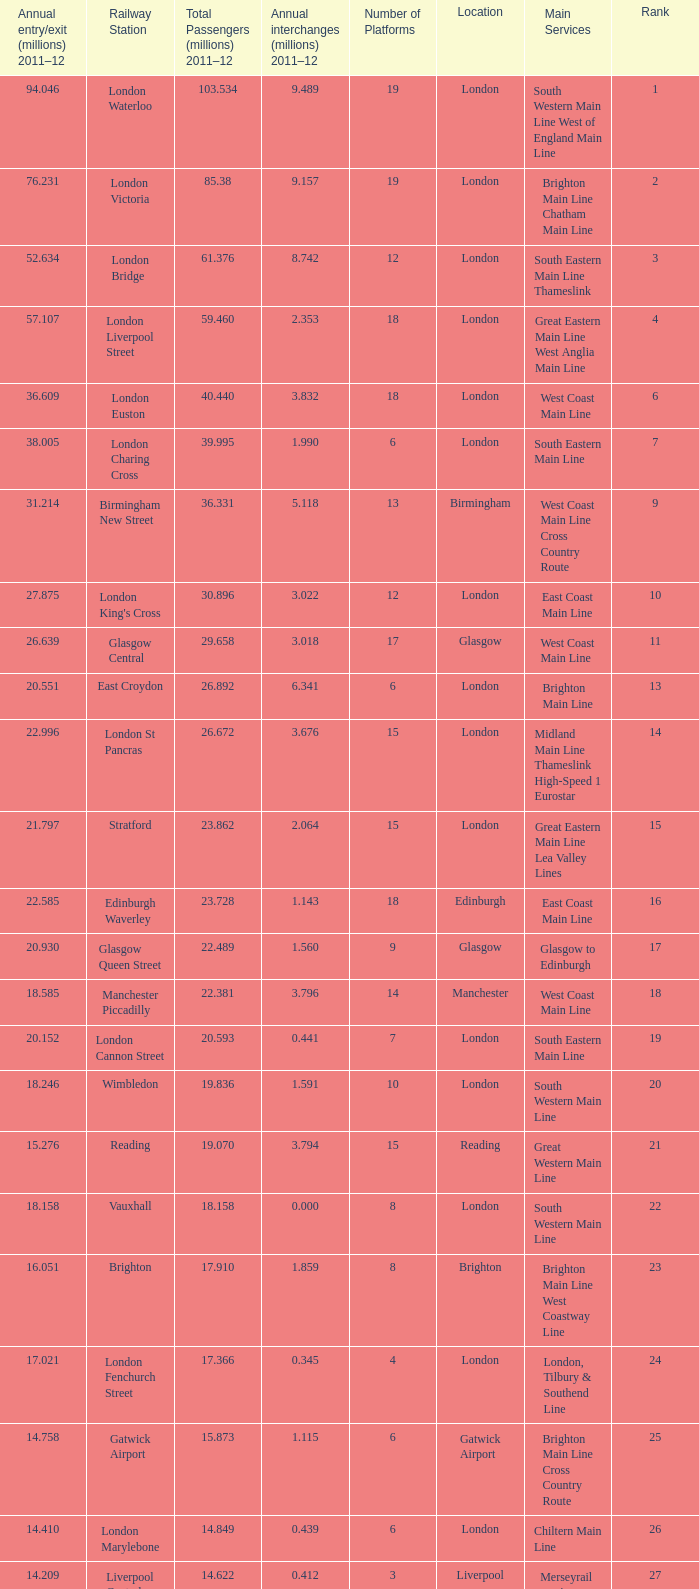Which location has 103.534 million passengers in 2011-12?  London. 